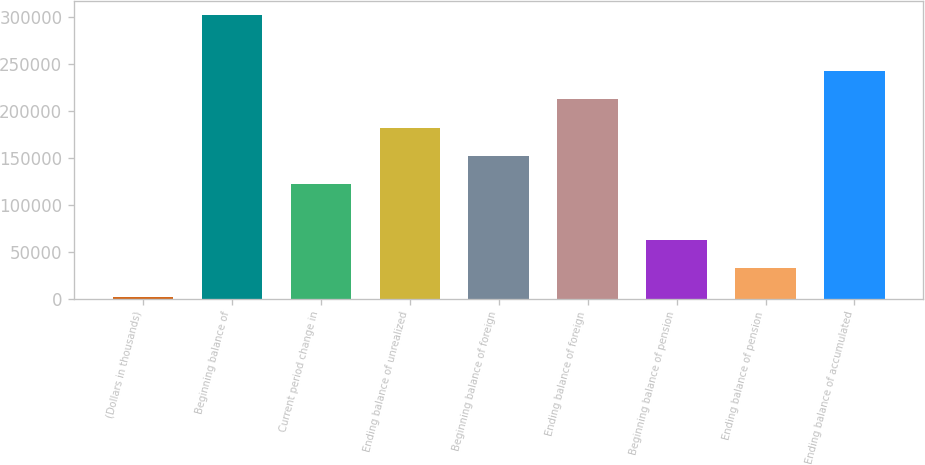Convert chart. <chart><loc_0><loc_0><loc_500><loc_500><bar_chart><fcel>(Dollars in thousands)<fcel>Beginning balance of<fcel>Current period change in<fcel>Ending balance of unrealized<fcel>Beginning balance of foreign<fcel>Ending balance of foreign<fcel>Beginning balance of pension<fcel>Ending balance of pension<fcel>Ending balance of accumulated<nl><fcel>2007<fcel>302856<fcel>122347<fcel>182516<fcel>152432<fcel>212601<fcel>62176.8<fcel>32091.9<fcel>242686<nl></chart> 